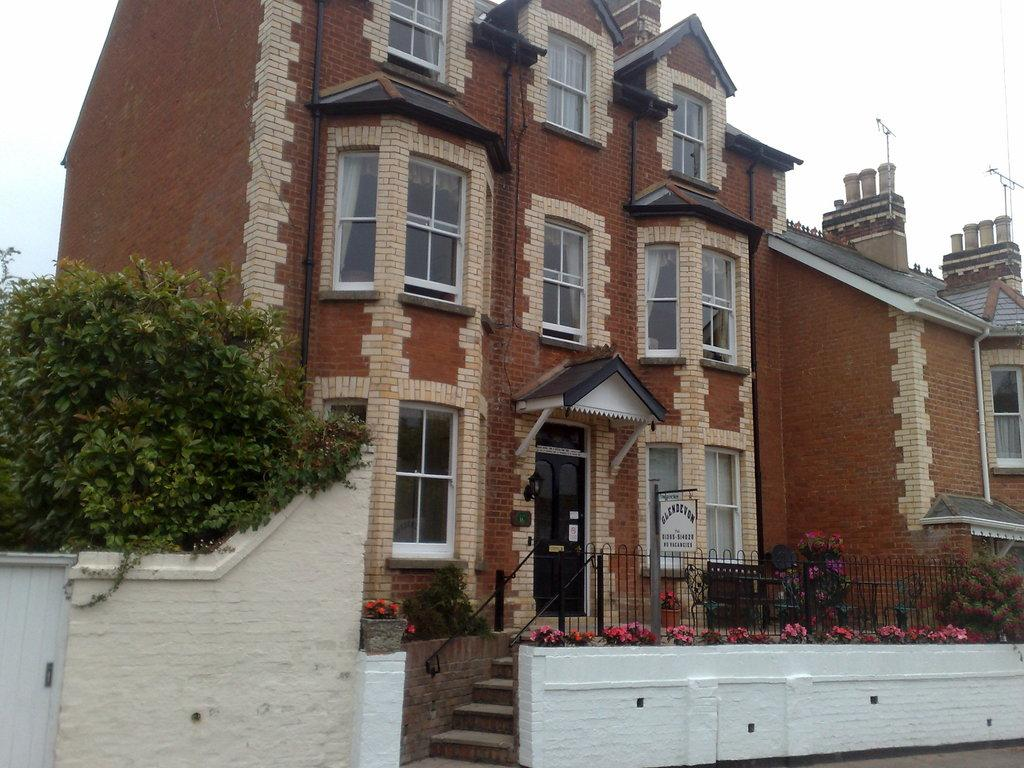What type of plants can be seen in the image? There are trailing plants and other plants in the image. Are there any flowers present in the image? Yes, there are flowers in the image. What is the purpose of the board in the image? The purpose of the board is not clear from the image, but it may be used for displaying information or decoration. What architectural feature is visible in the image? There are stairs in the image. What can be seen in the background of the image? There is a building with windows and the sky is visible in the background of the image. What verse is being recited by the cracker in the image? There is no cracker or verse present in the image. 